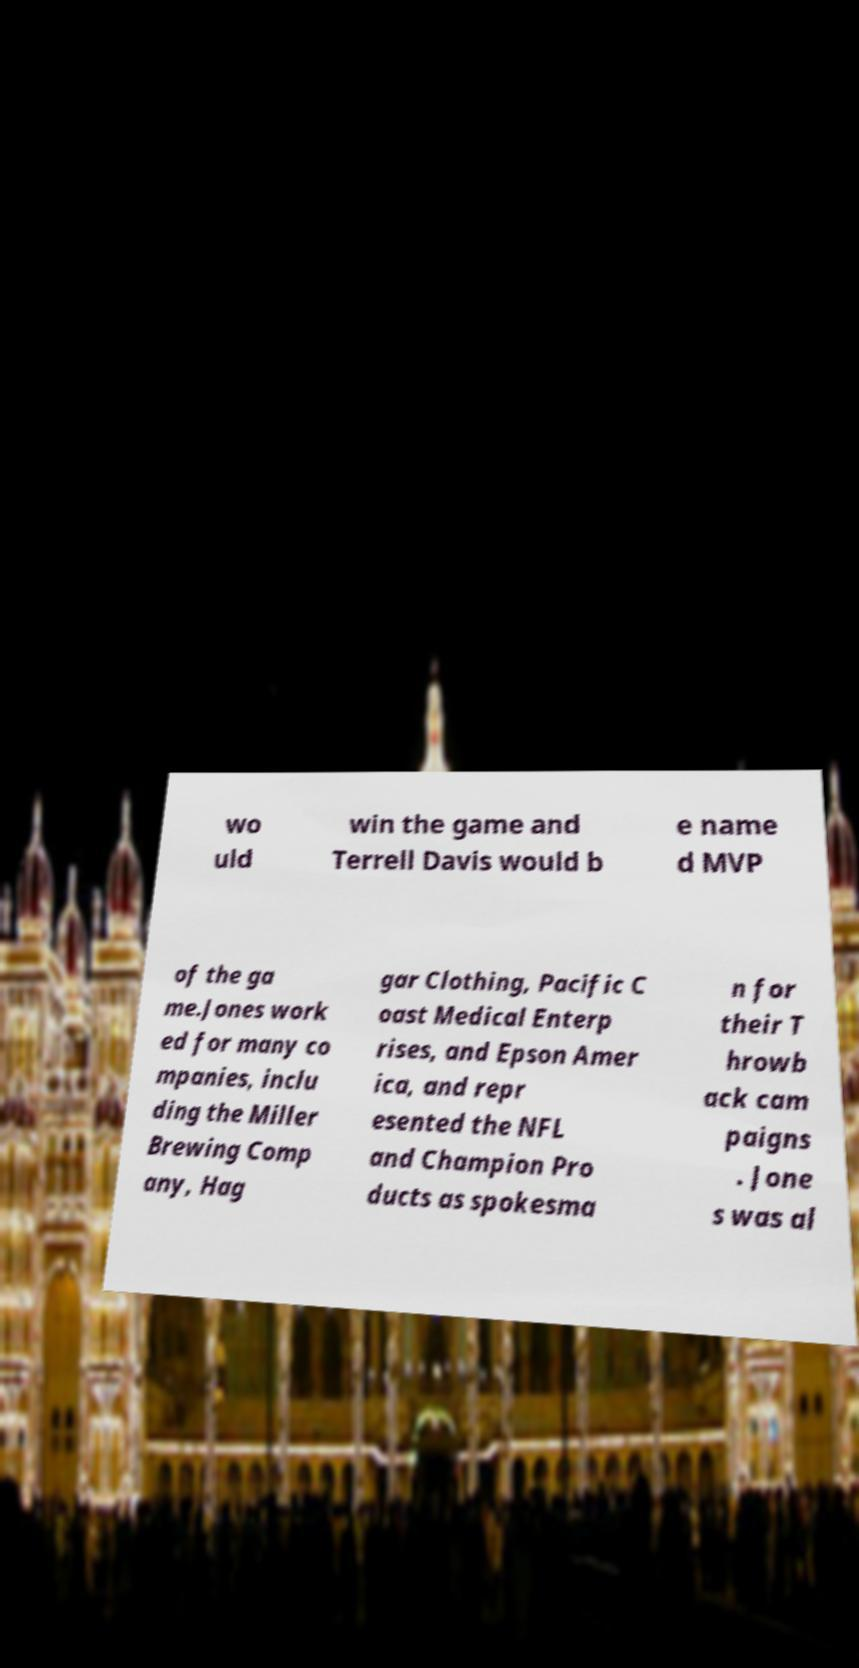Please read and relay the text visible in this image. What does it say? wo uld win the game and Terrell Davis would b e name d MVP of the ga me.Jones work ed for many co mpanies, inclu ding the Miller Brewing Comp any, Hag gar Clothing, Pacific C oast Medical Enterp rises, and Epson Amer ica, and repr esented the NFL and Champion Pro ducts as spokesma n for their T hrowb ack cam paigns . Jone s was al 